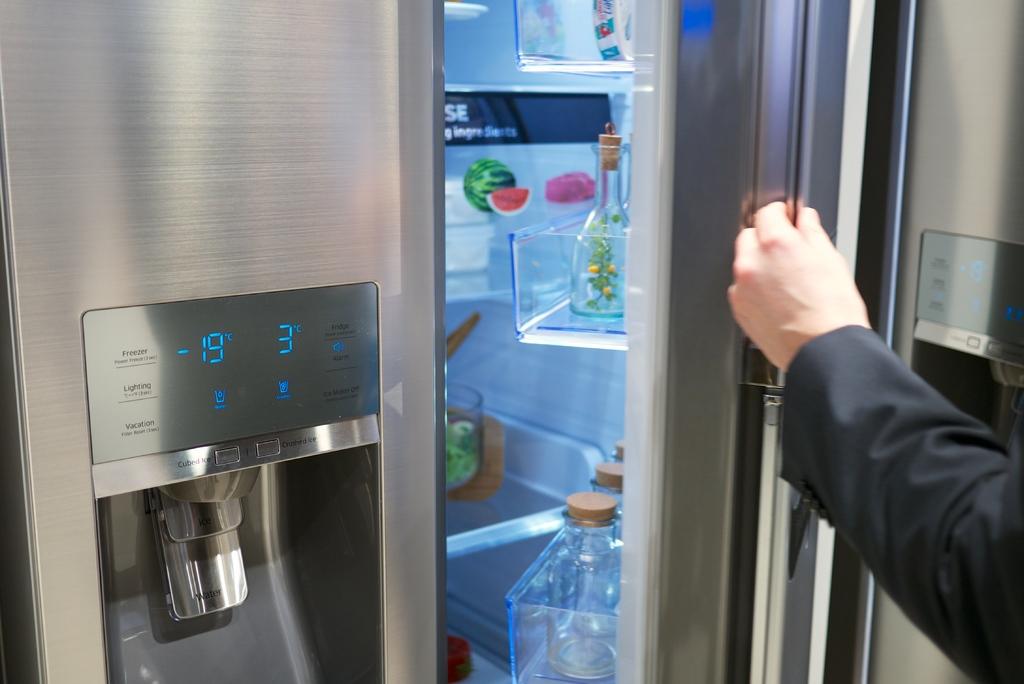What temperature is it set at?
Offer a terse response. -19. 